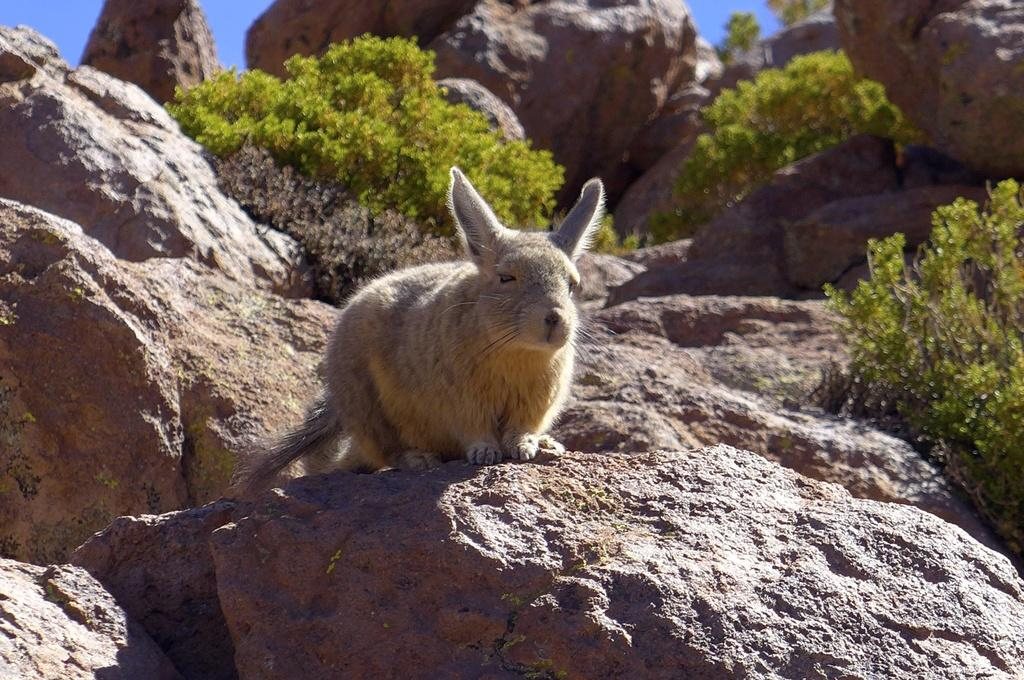What animal is in the front of the image? There is a rabbit in the front of the image. What can be seen in the background of the image? There are rocks and plants in the background of the image. What part of the sky is visible in the image? The sky is visible at the top left of the image. What type of treatment is the rabbit receiving in the image? There is no indication in the image that the rabbit is receiving any treatment. 